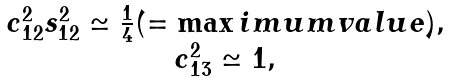Convert formula to latex. <formula><loc_0><loc_0><loc_500><loc_500>\begin{array} { c } c _ { 1 2 } ^ { 2 } s _ { 1 2 } ^ { 2 } \simeq \frac { 1 } { 4 } ( = \max i m u m v a l u e ) , \\ c _ { 1 3 } ^ { 2 } \simeq 1 , \end{array}</formula> 